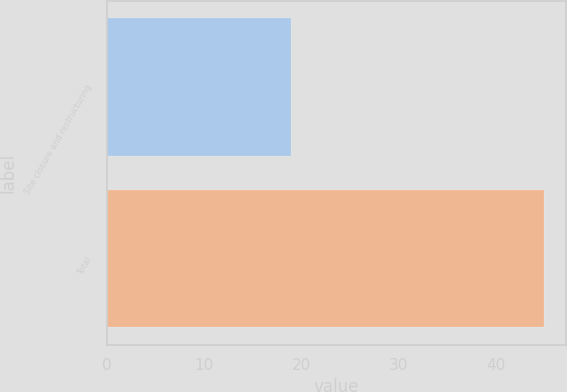Convert chart to OTSL. <chart><loc_0><loc_0><loc_500><loc_500><bar_chart><fcel>Site closure and restructuring<fcel>Total<nl><fcel>19<fcel>45<nl></chart> 